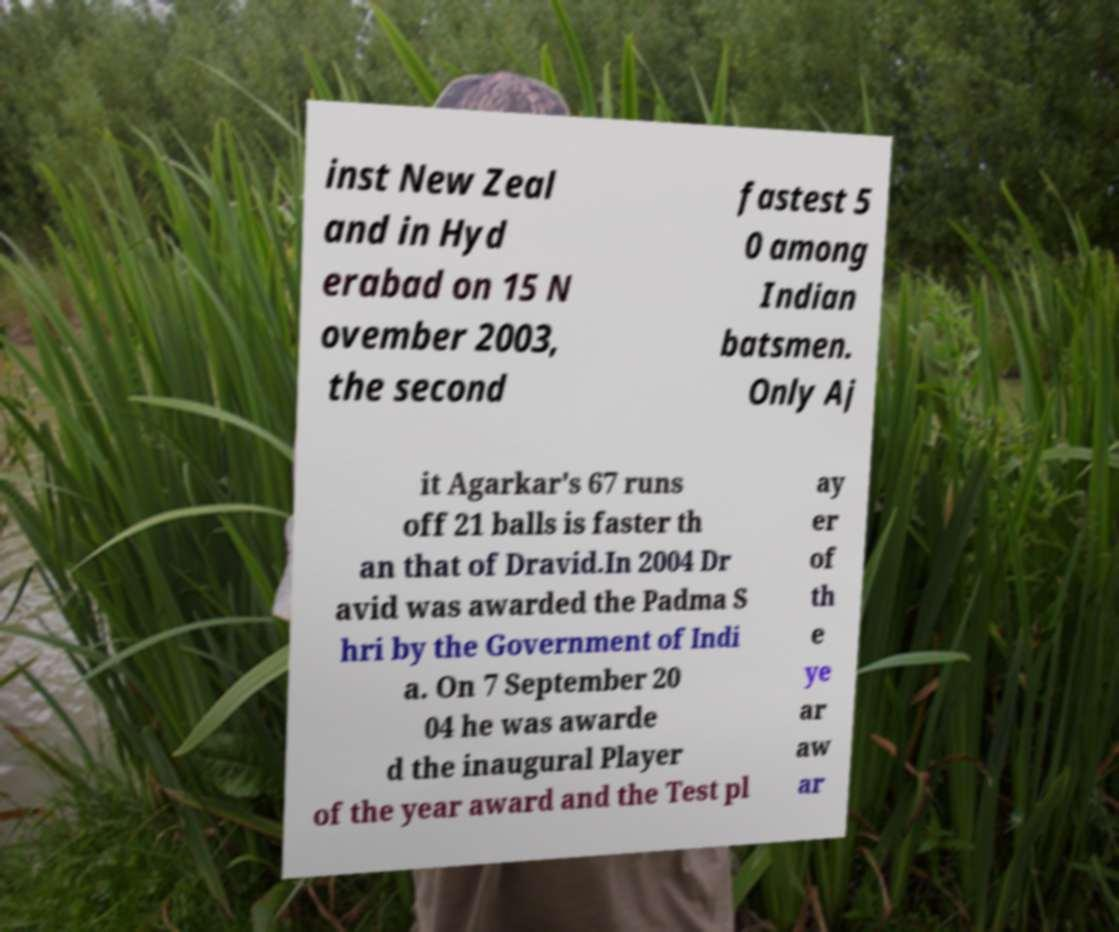Could you assist in decoding the text presented in this image and type it out clearly? inst New Zeal and in Hyd erabad on 15 N ovember 2003, the second fastest 5 0 among Indian batsmen. Only Aj it Agarkar's 67 runs off 21 balls is faster th an that of Dravid.In 2004 Dr avid was awarded the Padma S hri by the Government of Indi a. On 7 September 20 04 he was awarde d the inaugural Player of the year award and the Test pl ay er of th e ye ar aw ar 